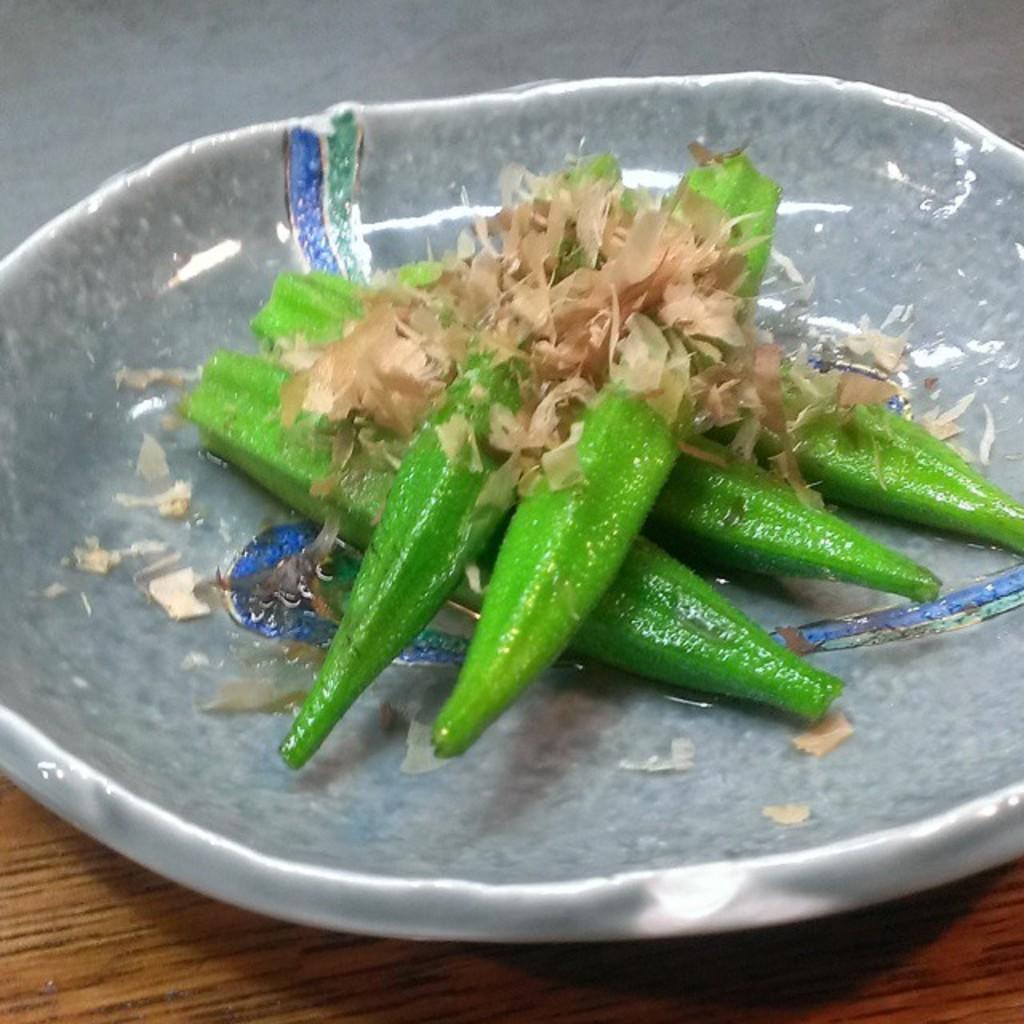In one or two sentences, can you explain what this image depicts? In this image, we can see few eatable things in the bowl. At the bottom, we can see wooden surface. Top of the image, we can see ash color. 